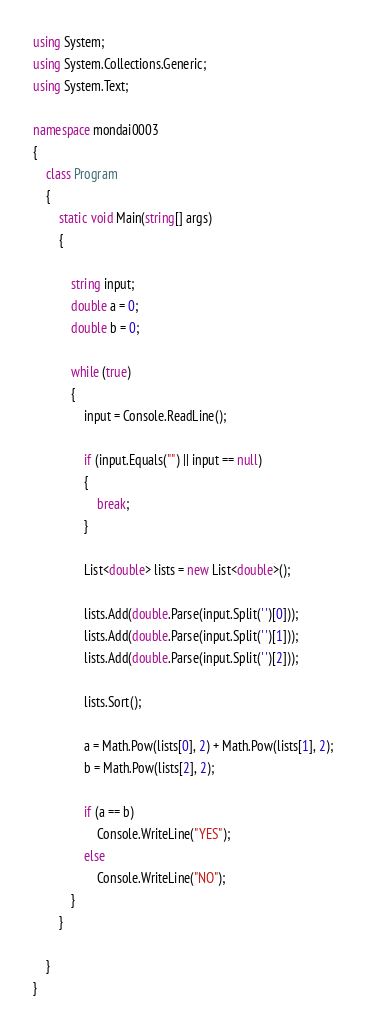<code> <loc_0><loc_0><loc_500><loc_500><_C#_>using System;
using System.Collections.Generic;
using System.Text;

namespace mondai0003
{
    class Program
    {
        static void Main(string[] args)
        {
            
            string input;
            double a = 0;
            double b = 0;

            while (true)
            {
                input = Console.ReadLine();

                if (input.Equals("") || input == null)
                {
                    break;
                }

                List<double> lists = new List<double>();

                lists.Add(double.Parse(input.Split(' ')[0]));
                lists.Add(double.Parse(input.Split(' ')[1]));
                lists.Add(double.Parse(input.Split(' ')[2]));    

                lists.Sort();

                a = Math.Pow(lists[0], 2) + Math.Pow(lists[1], 2);
                b = Math.Pow(lists[2], 2);

                if (a == b)
                    Console.WriteLine("YES");
                else
                    Console.WriteLine("NO");
            }
        }

    }
}</code> 